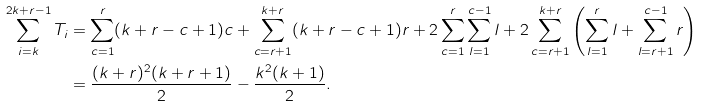<formula> <loc_0><loc_0><loc_500><loc_500>\sum _ { i = k } ^ { 2 k + r - 1 } T _ { i } & = \sum _ { c = 1 } ^ { r } ( k + r - c + 1 ) c + \sum _ { c = r + 1 } ^ { k + r } ( k + r - c + 1 ) r + 2 \sum _ { c = 1 } ^ { r } \sum _ { l = 1 } ^ { c - 1 } l + 2 \sum _ { c = r + 1 } ^ { k + r } \left ( \sum _ { l = 1 } ^ { r } l + \sum _ { l = r + 1 } ^ { c - 1 } r \right ) \\ & = \frac { ( k + r ) ^ { 2 } ( k + r + 1 ) } { 2 } - \frac { k ^ { 2 } ( k + 1 ) } { 2 } .</formula> 